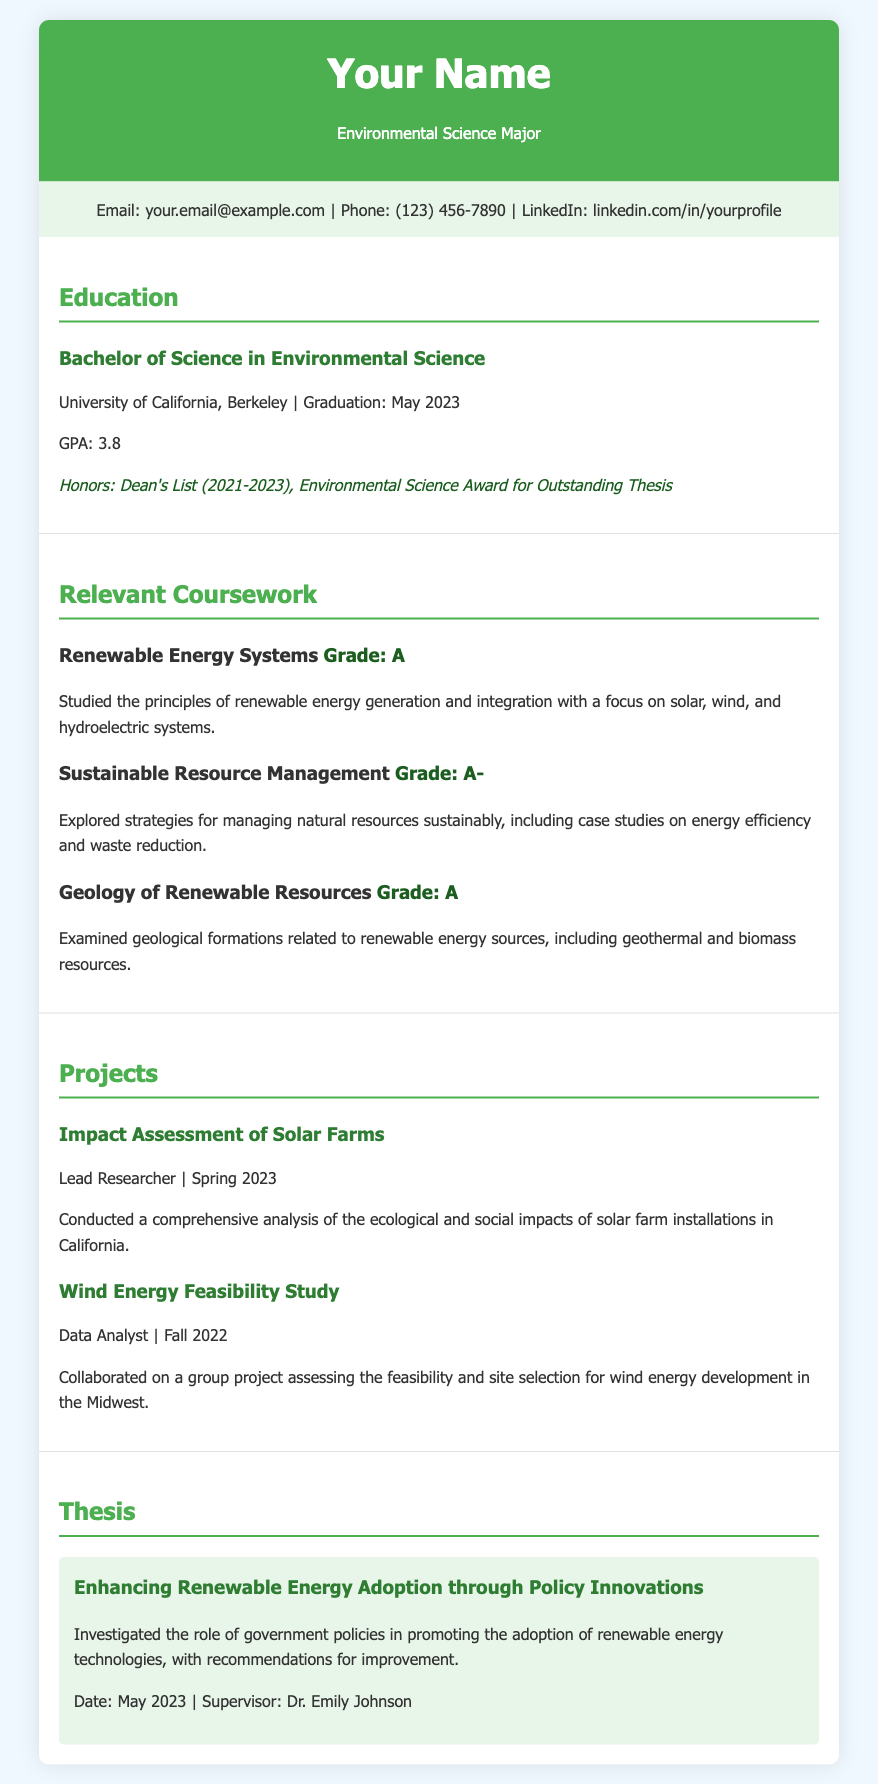What is the degree obtained? The document indicates the degree earned by the individual is a Bachelor of Science in Environmental Science.
Answer: Bachelor of Science in Environmental Science What is the GPA? The GPA is a measure of academic performance mentioned in the education section of the document.
Answer: 3.8 What honors were received? The document lists specific honors that the individual achieved during their studies.
Answer: Dean's List (2021-2023), Environmental Science Award for Outstanding Thesis What is the title of the thesis? The thesis title is a key piece of information provided in the thesis section of the document.
Answer: Enhancing Renewable Energy Adoption through Policy Innovations When was the thesis completed? The date mentioned in the thesis section indicates when the thesis was completed.
Answer: May 2023 What course received a grade of A-? The document specifies grades for specific courses taken by the individual.
Answer: Sustainable Resource Management What was the role in the Impact Assessment of Solar Farms project? The document states the individual’s specific role in the mentioned project.
Answer: Lead Researcher Which renewable energy sources are focused on in the Renewable Energy Systems course? The course description includes specific renewable energy systems that were studied.
Answer: solar, wind, and hydroelectric systems What university did the individual attend? The education section specifies the institution from which the degree was obtained.
Answer: University of California, Berkeley 